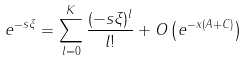Convert formula to latex. <formula><loc_0><loc_0><loc_500><loc_500>e ^ { - s \xi } = \sum _ { l = 0 } ^ { K } \frac { ( - s \xi ) ^ { l } } { l ! } + O \left ( e ^ { - x ( A + C ) } \right )</formula> 